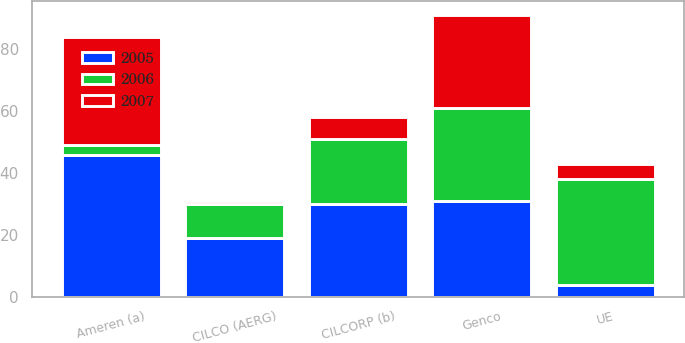Convert chart. <chart><loc_0><loc_0><loc_500><loc_500><stacked_bar_chart><ecel><fcel>Ameren (a)<fcel>UE<fcel>Genco<fcel>CILCORP (b)<fcel>CILCO (AERG)<nl><fcel>2007<fcel>35<fcel>5<fcel>30<fcel>7<fcel>1<nl><fcel>2006<fcel>3<fcel>34<fcel>30<fcel>21<fcel>11<nl><fcel>2005<fcel>46<fcel>4<fcel>31<fcel>30<fcel>19<nl></chart> 